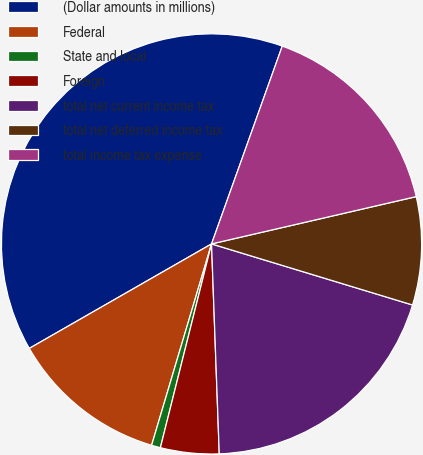<chart> <loc_0><loc_0><loc_500><loc_500><pie_chart><fcel>(Dollar amounts in millions)<fcel>Federal<fcel>State and local<fcel>Foreign<fcel>total net current income tax<fcel>total net deferred income tax<fcel>total income tax expense<nl><fcel>38.75%<fcel>12.11%<fcel>0.69%<fcel>4.5%<fcel>19.72%<fcel>8.31%<fcel>15.92%<nl></chart> 